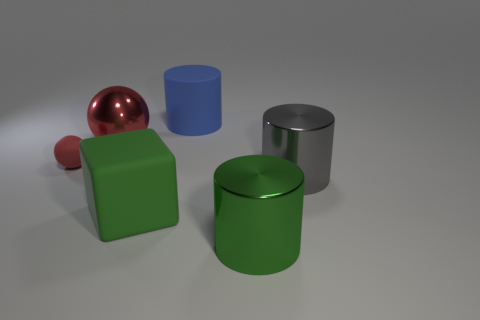What number of things are to the left of the large green cylinder and right of the tiny rubber object?
Give a very brief answer. 3. What is the material of the thing that is to the left of the large shiny thing on the left side of the large cylinder in front of the gray metal cylinder?
Make the answer very short. Rubber. How many other objects have the same material as the large red thing?
Give a very brief answer. 2. There is a small matte thing that is the same color as the large shiny sphere; what is its shape?
Provide a succinct answer. Sphere. What is the shape of the green shiny object that is the same size as the gray cylinder?
Offer a terse response. Cylinder. What material is the tiny object that is the same color as the shiny sphere?
Keep it short and to the point. Rubber. There is a blue matte object; are there any green things on the right side of it?
Keep it short and to the point. Yes. Is there a large gray thing that has the same shape as the big blue matte object?
Your answer should be compact. Yes. There is a red thing that is behind the small red rubber object; is it the same shape as the red object in front of the red metallic ball?
Ensure brevity in your answer.  Yes. Is there a green metallic cylinder that has the same size as the red matte thing?
Keep it short and to the point. No. 